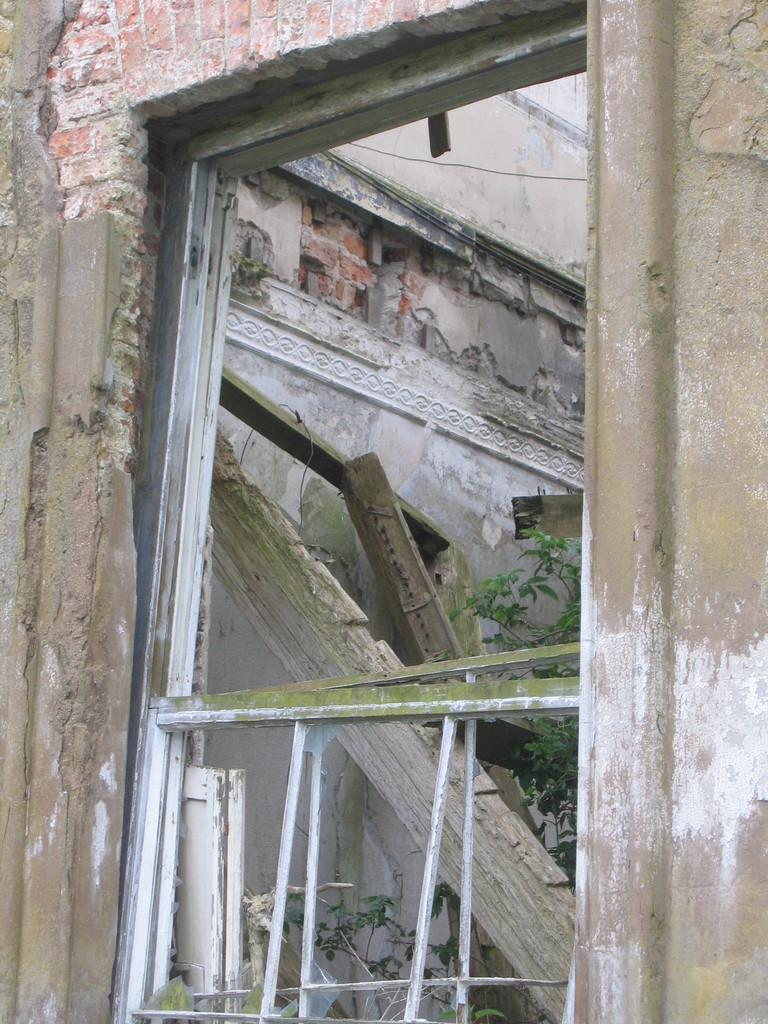What type of structure can be seen in the image? There is a wall in the image. What feature is present in the wall? There is a window in the image. What can be seen through the window? Another wall and wooden things are visible through the window. Can any natural elements be seen through the window? Yes, a plant is visible through the window. What country is visible through the window in the image? There is no country visible through the window in the image; it shows another wall, wooden things, and a plant. 